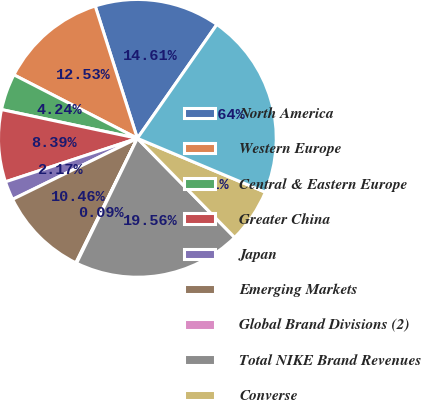<chart> <loc_0><loc_0><loc_500><loc_500><pie_chart><fcel>North America<fcel>Western Europe<fcel>Central & Eastern Europe<fcel>Greater China<fcel>Japan<fcel>Emerging Markets<fcel>Global Brand Divisions (2)<fcel>Total NIKE Brand Revenues<fcel>Converse<fcel>TOTAL NIKE INC REVENUES<nl><fcel>14.61%<fcel>12.53%<fcel>4.24%<fcel>8.39%<fcel>2.17%<fcel>10.46%<fcel>0.09%<fcel>19.56%<fcel>6.31%<fcel>21.64%<nl></chart> 